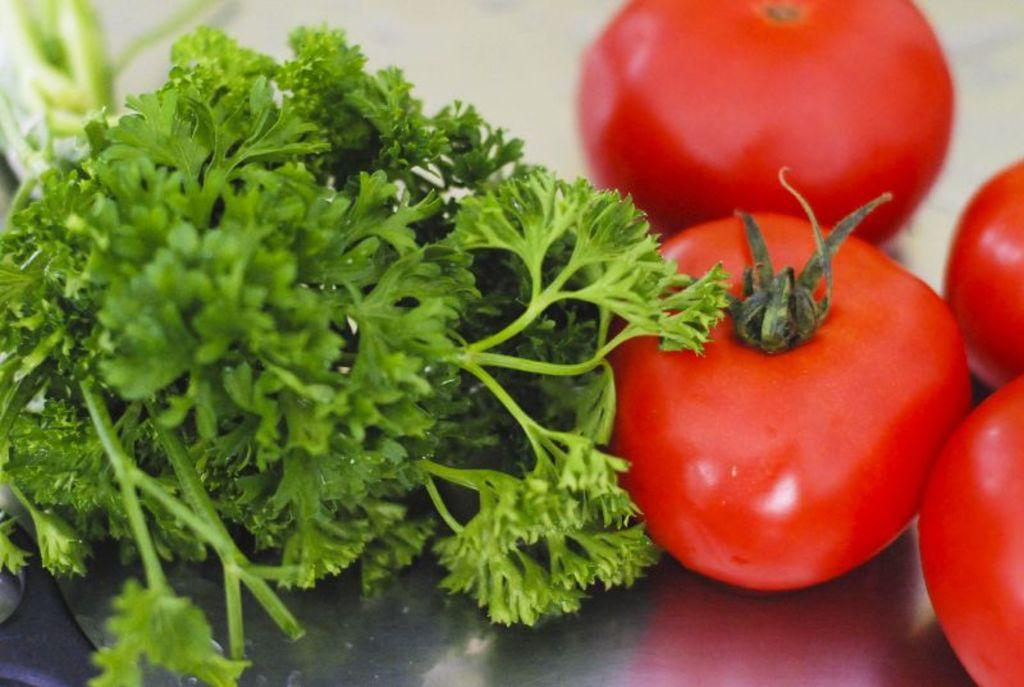What is on the plate that is visible in the image? There are tomatoes on the plate. Besides tomatoes, what other items can be seen on the plate? There is coriander on the plate. What type of bird can be seen sitting on the tomatoes in the image? There are no birds present in the image, so it is not possible to determine what type of bird might be sitting on the tomatoes. 